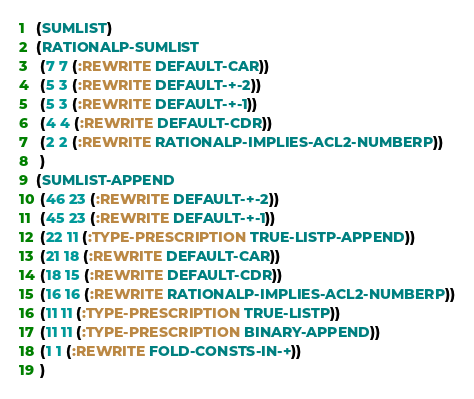<code> <loc_0><loc_0><loc_500><loc_500><_Lisp_>(SUMLIST)
(RATIONALP-SUMLIST
 (7 7 (:REWRITE DEFAULT-CAR))
 (5 3 (:REWRITE DEFAULT-+-2))
 (5 3 (:REWRITE DEFAULT-+-1))
 (4 4 (:REWRITE DEFAULT-CDR))
 (2 2 (:REWRITE RATIONALP-IMPLIES-ACL2-NUMBERP))
 )
(SUMLIST-APPEND
 (46 23 (:REWRITE DEFAULT-+-2))
 (45 23 (:REWRITE DEFAULT-+-1))
 (22 11 (:TYPE-PRESCRIPTION TRUE-LISTP-APPEND))
 (21 18 (:REWRITE DEFAULT-CAR))
 (18 15 (:REWRITE DEFAULT-CDR))
 (16 16 (:REWRITE RATIONALP-IMPLIES-ACL2-NUMBERP))
 (11 11 (:TYPE-PRESCRIPTION TRUE-LISTP))
 (11 11 (:TYPE-PRESCRIPTION BINARY-APPEND))
 (1 1 (:REWRITE FOLD-CONSTS-IN-+))
 )
</code> 